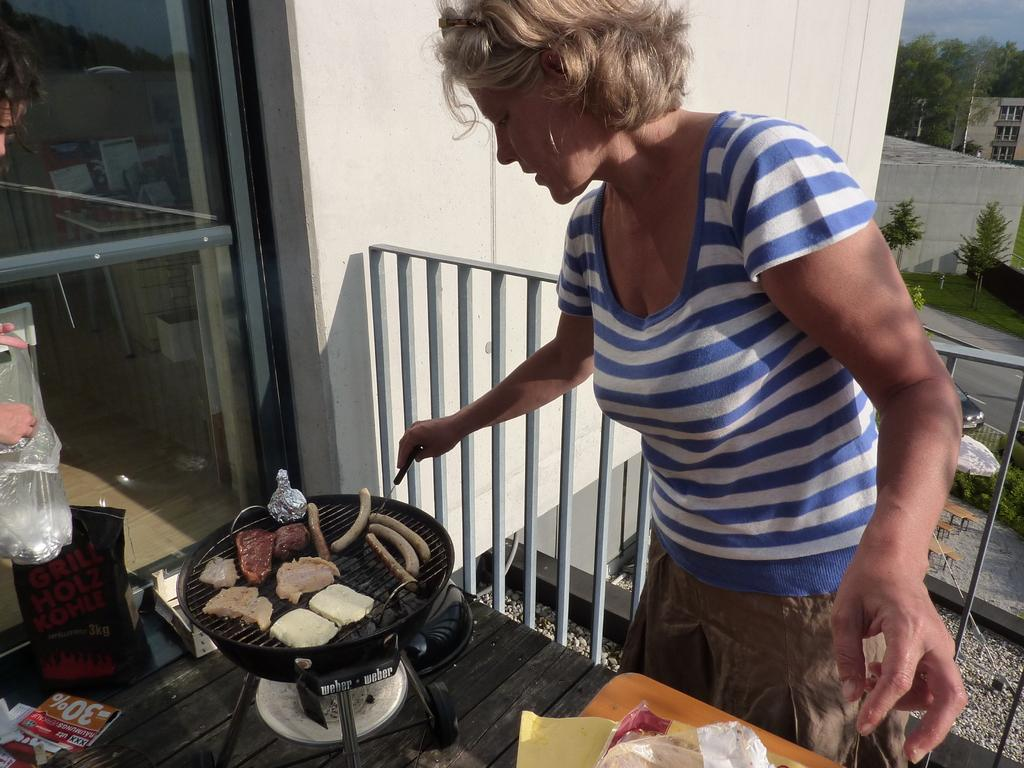<image>
Give a short and clear explanation of the subsequent image. Woman cooking some meat near a paper that says 30%. 